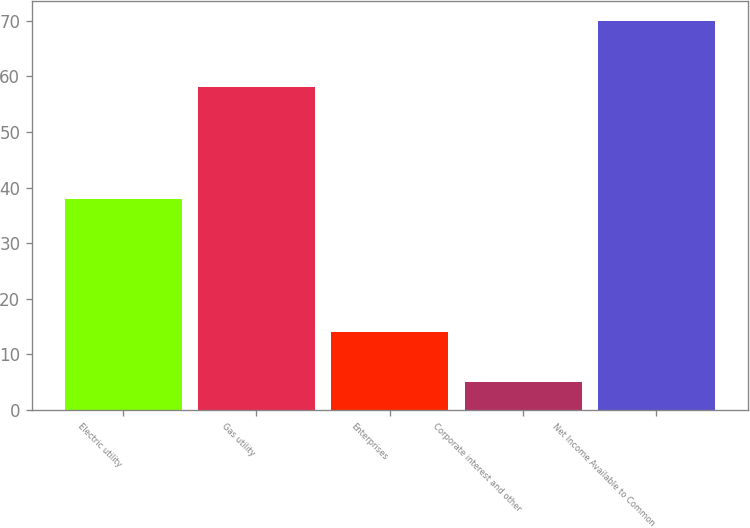Convert chart. <chart><loc_0><loc_0><loc_500><loc_500><bar_chart><fcel>Electric utility<fcel>Gas utility<fcel>Enterprises<fcel>Corporate interest and other<fcel>Net Income Available to Common<nl><fcel>38<fcel>58<fcel>14<fcel>5<fcel>70<nl></chart> 